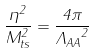<formula> <loc_0><loc_0><loc_500><loc_500>\frac { \eta ^ { 2 } } { M _ { t s } ^ { 2 } } = \frac { 4 \pi } { { \Lambda _ { A A } } ^ { 2 } }</formula> 